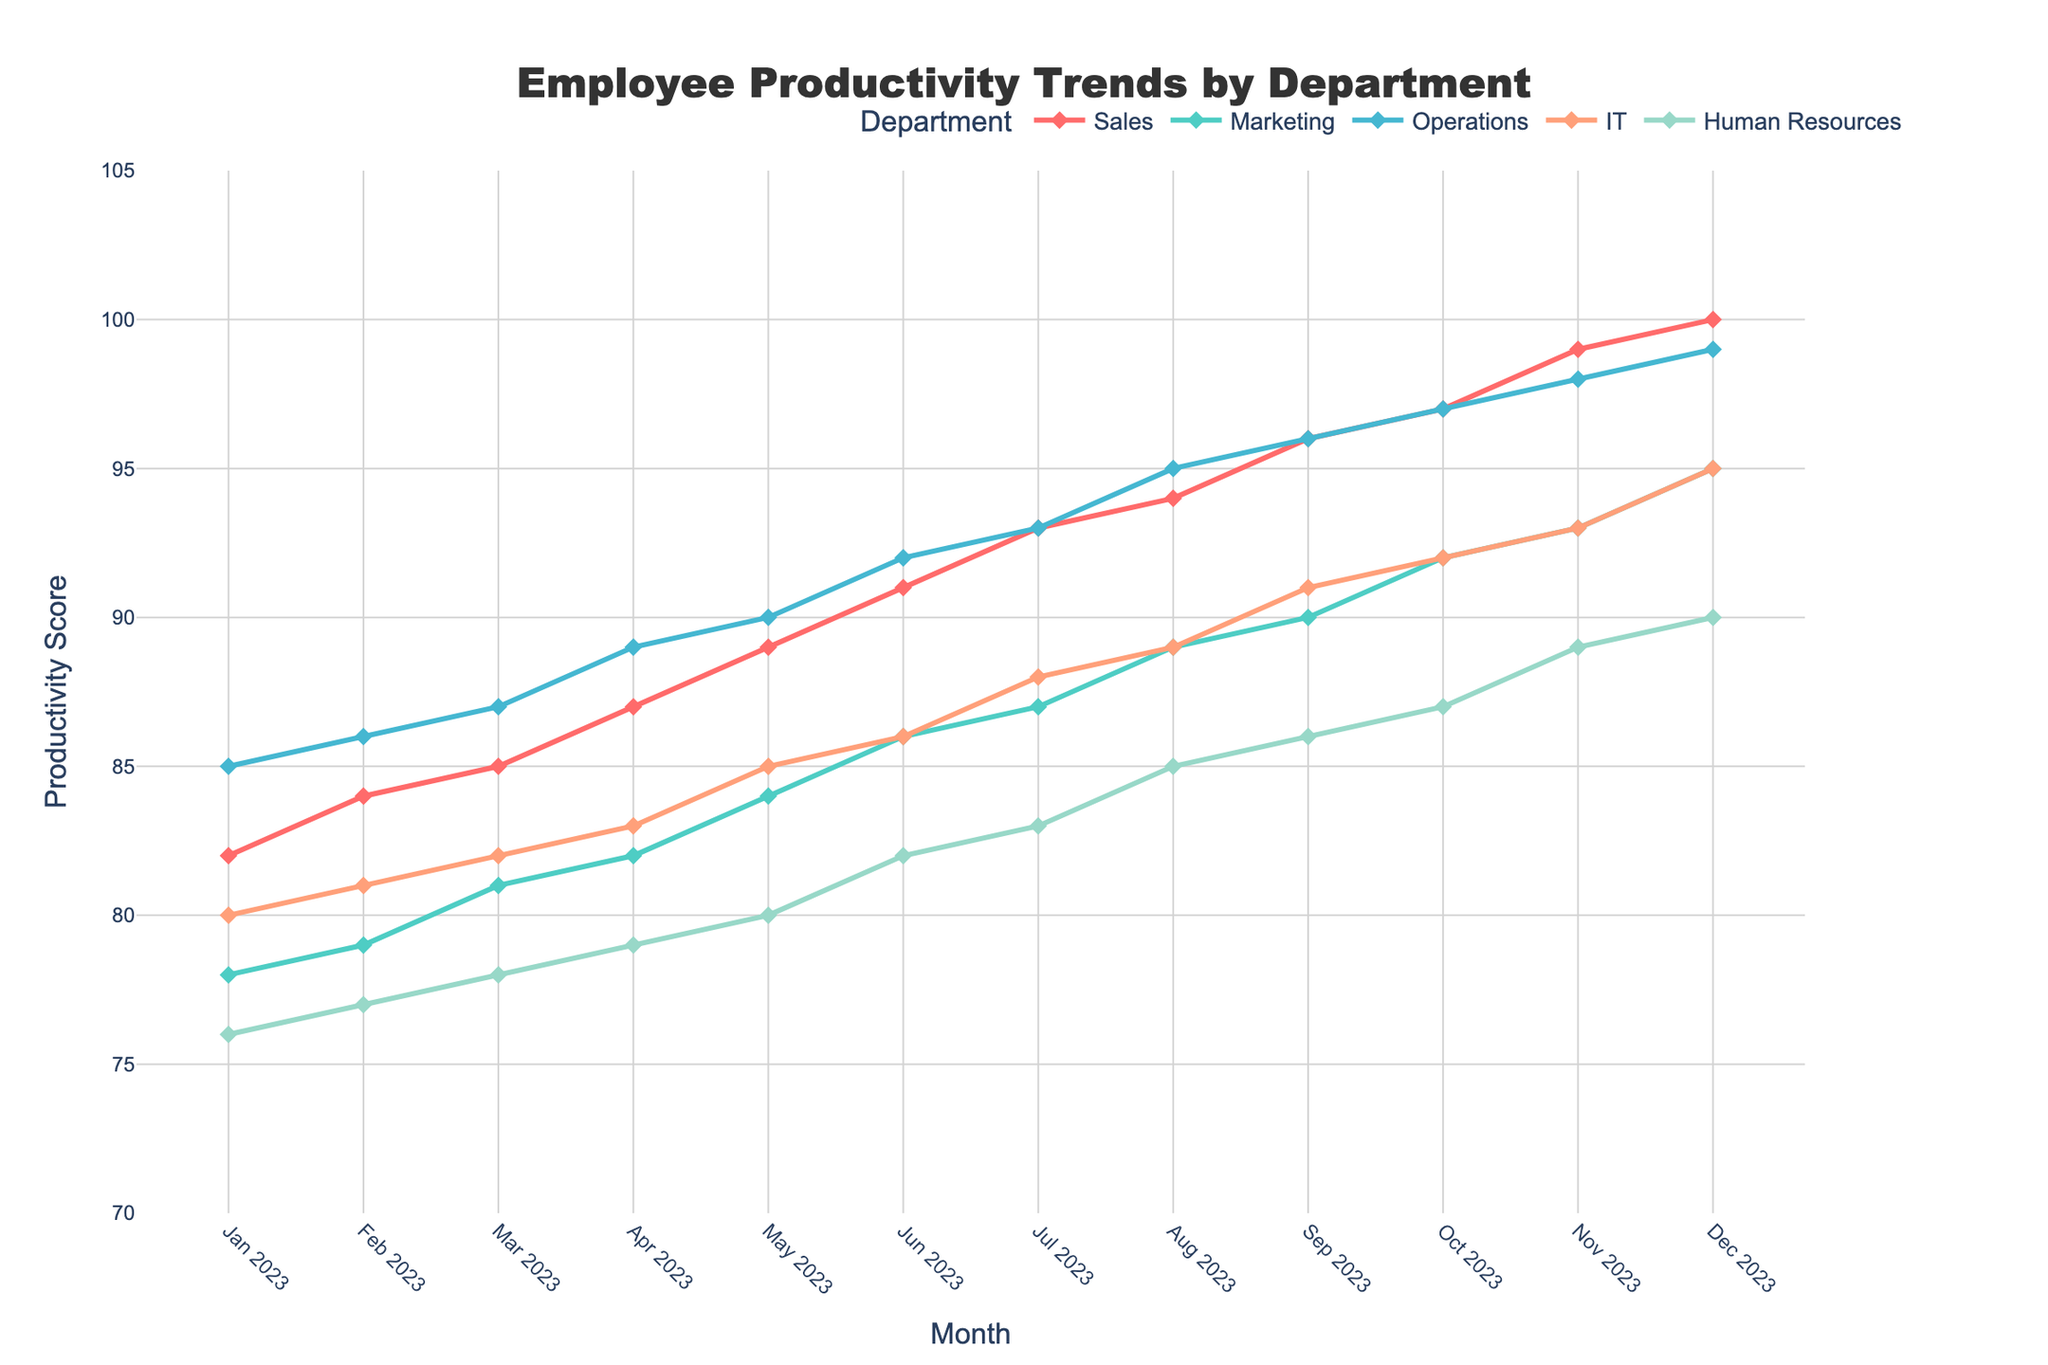What's the overall trend in employee productivity across all departments from Jan 2023 to Dec 2023? To assess the overall trend, observe the productivity scores for each department over the months. Each line generally shows an upward trend, indicating that employee productivity has increased from January to December.
Answer: Increasing Which department had the highest productivity score in December 2023? Look at the end points of each line at December 2023 on the x-axis. The productivity scores are: Sales (100), Marketing (95), Operations (99), IT (95), Human Resources (90). The highest score is in Sales with 100.
Answer: Sales By how many points did IT's productivity increase from Jan 2023 to Dec 2023? Subtract IT's productivity score in January 2023 (80) from its score in December 2023 (95). \( 95 - 80 = 15 \)
Answer: 15 Which months had the most significant increase in Human Resources productivity? Compare the slope of the Human Resources line between all adjacent months. The steepest slopes indicate the most significant increases. The largest increase occurs between June 2023 (82) and July 2023 (83), and also between November 2023 (89) and December 2023 (90).
Answer: June to July, November to December What’s the average productivity score of Marketing for the first quarter of 2023? Average the scores for Marketing from January, February, and March. \( \frac{78 + 79 + 81}{3} = 79.33 \)
Answer: 79.33 How does the upward trend in Operations compare to Marketing over the year? Compare the slopes and end points of the Operations and Marketing lines. Operations started at 85 and ended at 99 for an increase of 14 points. Marketing went from 78 to 95 for an increase of 17 points. Both have upward trends, but Marketing has a slightly steeper increase.
Answer: Marketing increased more During which month did the Sales department experience the highest productivity increase from the previous month? Calculate the month-on-month increase for Sales. The highest increase is between Oct 2023 (97) and Nov 2023 (99) with an increase of \( 99 - 97 = 2 \) points.
Answer: November Which two departments have productivity scores most closely aligned in October 2023? Compare the productivity scores for all departments in October 2023. IT and Operations both have a score of 92, which are the closest.
Answer: IT and Operations Which department shows the steadier and most consistent growth throughout the year? Examine the lines for erratic behavior or consistent, steady growth. The lines for Sales are the smoothest with consistent increments each month.
Answer: Sales 